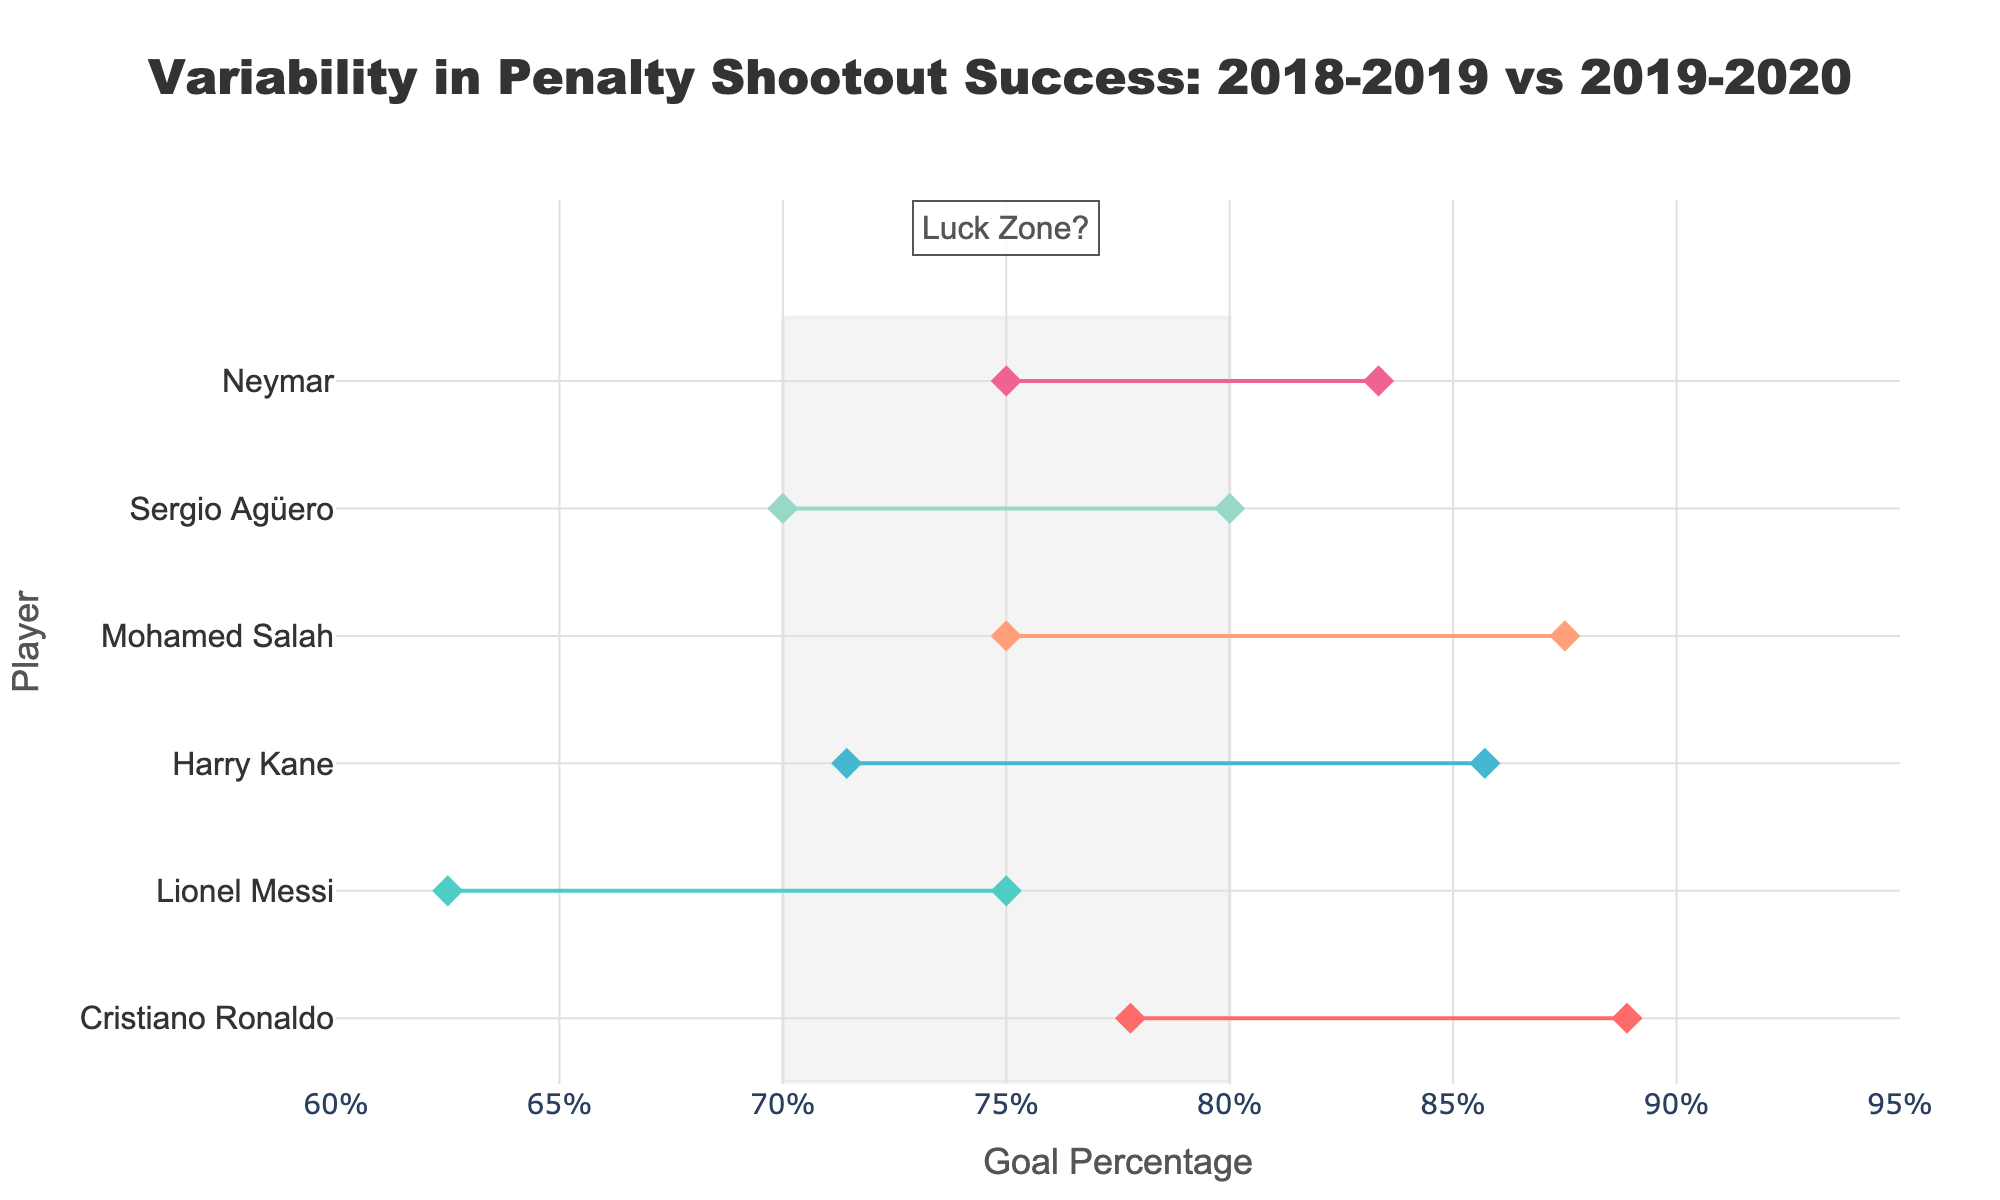What is the title of the plot? The title of the plot is prominently displayed at the top. It reads "Variability in Penalty Shootout Success: 2018-2019 vs 2019-2020."
Answer: Variability in Penalty Shootout Success: 2018-2019 vs 2019-2020 Which player had the highest goal percentage in the 2018-2019 season? By observing the markers and hovering over them in the figure, we can identify that Cristiano Ronaldo (with Manchester United) had the highest goal percentage of 77.78% in the 2018-2019 season.
Answer: Cristiano Ronaldo How does Mohamed Salah's goal percentage change from the 2018-2019 season to the 2019-2020 season? By looking at the line connecting his two markers, Mohamed Salah's goal percentage decreased from 87.50% in the 2018-2019 season to 75.00% in the 2019-2020 season.
Answer: Decreased from 87.50% to 75.00% Which player had the most significant improvement in goal percentage between the two seasons? By comparing the distances between the two markers for each player, Cristiano Ronaldo had the most significant improvement, increasing from 77.78% to 88.89%.
Answer: Cristiano Ronaldo What is the light gray shaded region in the plot supposed to signify? The light gray shaded region is labeled as "Luck Zone?" and it covers the goal percentages between 70% and 80%, indicating a potential area where variability might be influenced by luck.
Answer: Luck Zone? Which team had two players featured in the plot? Manchester City is the team with two different players (Cristiano Ronaldo and Harry Kane).
Answer: Manchester City How many players had a goal percentage below 70% in any season? By examining the figure, players with markers within the range of less than 70% can be counted. Lionel Messi (2018-2019), Sergio Agüero (2018-2019)
Answer: Two players Which player had the least variability in their goal percentages over the two seasons? By examining the vertical distance between the two markers for each player, Neymar had the least variability, with goal percentages very close at 75.00% and 83.33%.
Answer: Neymar What is the range of goal percentages shown on the x-axis? The x-axis ranges from 60% to 95%, as indicated by the axis labels.
Answer: 60% to 95% From the figure, which season had overall higher goal percentages? By comparing the positions of markers for both seasons, it is generally observed that the goal percentages in the 2019-2020 season are higher overall compared to the 2018-2019 season.
Answer: 2019-2020 season 